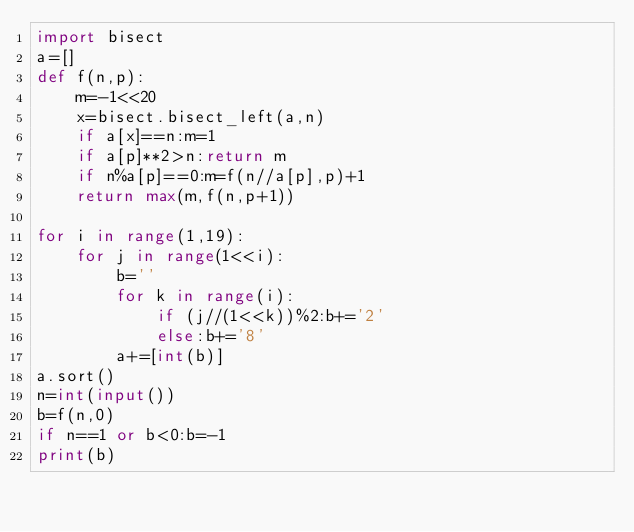Convert code to text. <code><loc_0><loc_0><loc_500><loc_500><_Python_>import bisect
a=[]
def f(n,p):
    m=-1<<20
    x=bisect.bisect_left(a,n)
    if a[x]==n:m=1
    if a[p]**2>n:return m
    if n%a[p]==0:m=f(n//a[p],p)+1
    return max(m,f(n,p+1))

for i in range(1,19):
    for j in range(1<<i):
        b=''
        for k in range(i):
            if (j//(1<<k))%2:b+='2'
            else:b+='8'
        a+=[int(b)]
a.sort()
n=int(input())
b=f(n,0)
if n==1 or b<0:b=-1
print(b)</code> 